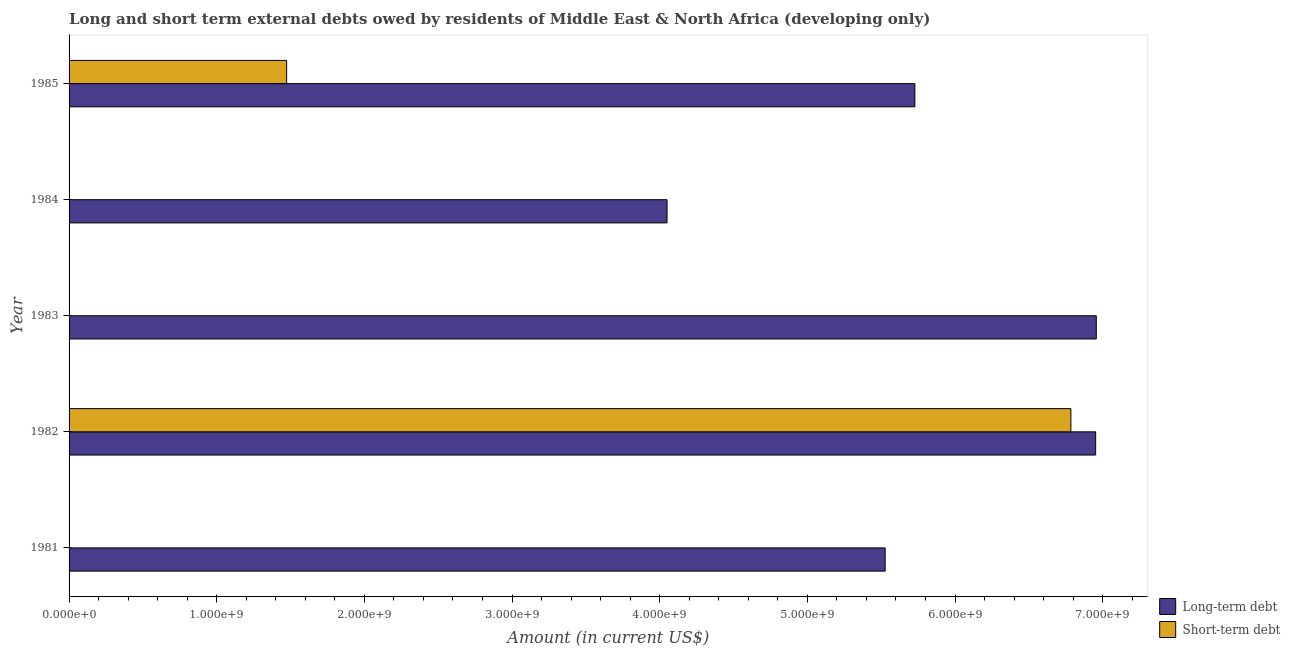How many different coloured bars are there?
Your response must be concise. 2. How many bars are there on the 1st tick from the top?
Your response must be concise. 2. How many bars are there on the 4th tick from the bottom?
Provide a succinct answer. 1. What is the long-term debts owed by residents in 1982?
Provide a succinct answer. 6.95e+09. Across all years, what is the maximum long-term debts owed by residents?
Your answer should be compact. 6.96e+09. Across all years, what is the minimum long-term debts owed by residents?
Your answer should be very brief. 4.05e+09. In which year was the long-term debts owed by residents maximum?
Give a very brief answer. 1983. What is the total long-term debts owed by residents in the graph?
Provide a short and direct response. 2.92e+1. What is the difference between the short-term debts owed by residents in 1982 and that in 1985?
Make the answer very short. 5.31e+09. What is the difference between the long-term debts owed by residents in 1985 and the short-term debts owed by residents in 1983?
Make the answer very short. 5.73e+09. What is the average short-term debts owed by residents per year?
Provide a short and direct response. 1.65e+09. In the year 1985, what is the difference between the short-term debts owed by residents and long-term debts owed by residents?
Offer a terse response. -4.25e+09. In how many years, is the short-term debts owed by residents greater than 4400000000 US$?
Keep it short and to the point. 1. What is the ratio of the long-term debts owed by residents in 1981 to that in 1985?
Keep it short and to the point. 0.96. Is the long-term debts owed by residents in 1981 less than that in 1983?
Offer a very short reply. Yes. What is the difference between the highest and the second highest long-term debts owed by residents?
Your answer should be very brief. 4.38e+06. What is the difference between the highest and the lowest short-term debts owed by residents?
Your response must be concise. 6.78e+09. In how many years, is the short-term debts owed by residents greater than the average short-term debts owed by residents taken over all years?
Your answer should be very brief. 1. How many bars are there?
Offer a very short reply. 7. Are all the bars in the graph horizontal?
Keep it short and to the point. Yes. Does the graph contain any zero values?
Your answer should be compact. Yes. Where does the legend appear in the graph?
Ensure brevity in your answer.  Bottom right. What is the title of the graph?
Ensure brevity in your answer.  Long and short term external debts owed by residents of Middle East & North Africa (developing only). Does "From World Bank" appear as one of the legend labels in the graph?
Your answer should be very brief. No. What is the label or title of the X-axis?
Your answer should be compact. Amount (in current US$). What is the label or title of the Y-axis?
Your response must be concise. Year. What is the Amount (in current US$) of Long-term debt in 1981?
Your response must be concise. 5.53e+09. What is the Amount (in current US$) in Long-term debt in 1982?
Your response must be concise. 6.95e+09. What is the Amount (in current US$) of Short-term debt in 1982?
Offer a terse response. 6.78e+09. What is the Amount (in current US$) in Long-term debt in 1983?
Offer a terse response. 6.96e+09. What is the Amount (in current US$) of Short-term debt in 1983?
Provide a succinct answer. 0. What is the Amount (in current US$) in Long-term debt in 1984?
Your answer should be compact. 4.05e+09. What is the Amount (in current US$) in Long-term debt in 1985?
Your answer should be very brief. 5.73e+09. What is the Amount (in current US$) in Short-term debt in 1985?
Offer a terse response. 1.47e+09. Across all years, what is the maximum Amount (in current US$) of Long-term debt?
Provide a short and direct response. 6.96e+09. Across all years, what is the maximum Amount (in current US$) of Short-term debt?
Offer a very short reply. 6.78e+09. Across all years, what is the minimum Amount (in current US$) of Long-term debt?
Your answer should be very brief. 4.05e+09. What is the total Amount (in current US$) in Long-term debt in the graph?
Your answer should be very brief. 2.92e+1. What is the total Amount (in current US$) in Short-term debt in the graph?
Provide a short and direct response. 8.26e+09. What is the difference between the Amount (in current US$) in Long-term debt in 1981 and that in 1982?
Offer a terse response. -1.43e+09. What is the difference between the Amount (in current US$) of Long-term debt in 1981 and that in 1983?
Keep it short and to the point. -1.43e+09. What is the difference between the Amount (in current US$) in Long-term debt in 1981 and that in 1984?
Offer a very short reply. 1.48e+09. What is the difference between the Amount (in current US$) in Long-term debt in 1981 and that in 1985?
Give a very brief answer. -2.01e+08. What is the difference between the Amount (in current US$) in Long-term debt in 1982 and that in 1983?
Provide a succinct answer. -4.38e+06. What is the difference between the Amount (in current US$) in Long-term debt in 1982 and that in 1984?
Make the answer very short. 2.90e+09. What is the difference between the Amount (in current US$) in Long-term debt in 1982 and that in 1985?
Provide a succinct answer. 1.22e+09. What is the difference between the Amount (in current US$) of Short-term debt in 1982 and that in 1985?
Your response must be concise. 5.31e+09. What is the difference between the Amount (in current US$) of Long-term debt in 1983 and that in 1984?
Your answer should be compact. 2.91e+09. What is the difference between the Amount (in current US$) of Long-term debt in 1983 and that in 1985?
Your answer should be very brief. 1.23e+09. What is the difference between the Amount (in current US$) in Long-term debt in 1984 and that in 1985?
Ensure brevity in your answer.  -1.68e+09. What is the difference between the Amount (in current US$) in Long-term debt in 1981 and the Amount (in current US$) in Short-term debt in 1982?
Offer a very short reply. -1.26e+09. What is the difference between the Amount (in current US$) in Long-term debt in 1981 and the Amount (in current US$) in Short-term debt in 1985?
Your response must be concise. 4.05e+09. What is the difference between the Amount (in current US$) in Long-term debt in 1982 and the Amount (in current US$) in Short-term debt in 1985?
Your response must be concise. 5.48e+09. What is the difference between the Amount (in current US$) in Long-term debt in 1983 and the Amount (in current US$) in Short-term debt in 1985?
Keep it short and to the point. 5.48e+09. What is the difference between the Amount (in current US$) of Long-term debt in 1984 and the Amount (in current US$) of Short-term debt in 1985?
Your answer should be compact. 2.58e+09. What is the average Amount (in current US$) in Long-term debt per year?
Provide a succinct answer. 5.84e+09. What is the average Amount (in current US$) of Short-term debt per year?
Give a very brief answer. 1.65e+09. In the year 1982, what is the difference between the Amount (in current US$) of Long-term debt and Amount (in current US$) of Short-term debt?
Offer a very short reply. 1.68e+08. In the year 1985, what is the difference between the Amount (in current US$) in Long-term debt and Amount (in current US$) in Short-term debt?
Offer a very short reply. 4.25e+09. What is the ratio of the Amount (in current US$) in Long-term debt in 1981 to that in 1982?
Keep it short and to the point. 0.8. What is the ratio of the Amount (in current US$) of Long-term debt in 1981 to that in 1983?
Provide a succinct answer. 0.79. What is the ratio of the Amount (in current US$) in Long-term debt in 1981 to that in 1984?
Offer a very short reply. 1.36. What is the ratio of the Amount (in current US$) in Long-term debt in 1981 to that in 1985?
Offer a terse response. 0.96. What is the ratio of the Amount (in current US$) of Long-term debt in 1982 to that in 1983?
Your answer should be very brief. 1. What is the ratio of the Amount (in current US$) of Long-term debt in 1982 to that in 1984?
Your answer should be very brief. 1.72. What is the ratio of the Amount (in current US$) of Long-term debt in 1982 to that in 1985?
Give a very brief answer. 1.21. What is the ratio of the Amount (in current US$) of Short-term debt in 1982 to that in 1985?
Give a very brief answer. 4.6. What is the ratio of the Amount (in current US$) of Long-term debt in 1983 to that in 1984?
Provide a succinct answer. 1.72. What is the ratio of the Amount (in current US$) of Long-term debt in 1983 to that in 1985?
Give a very brief answer. 1.21. What is the ratio of the Amount (in current US$) of Long-term debt in 1984 to that in 1985?
Provide a succinct answer. 0.71. What is the difference between the highest and the second highest Amount (in current US$) of Long-term debt?
Keep it short and to the point. 4.38e+06. What is the difference between the highest and the lowest Amount (in current US$) in Long-term debt?
Give a very brief answer. 2.91e+09. What is the difference between the highest and the lowest Amount (in current US$) of Short-term debt?
Your answer should be compact. 6.78e+09. 